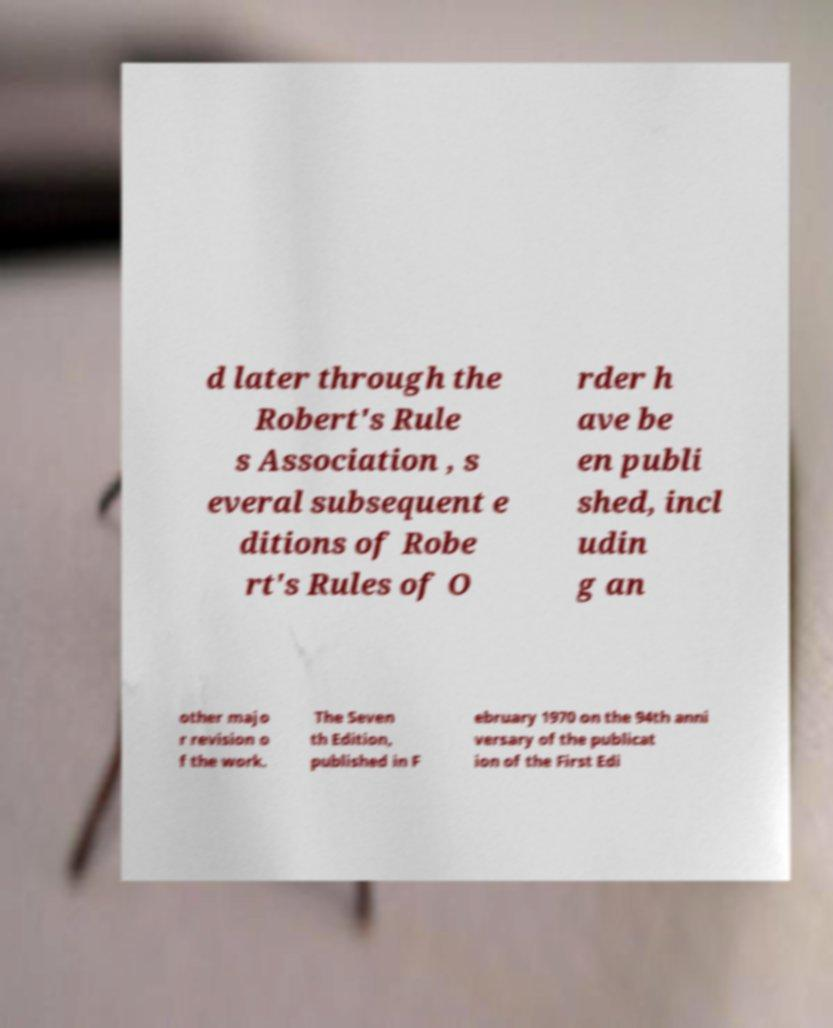Can you read and provide the text displayed in the image?This photo seems to have some interesting text. Can you extract and type it out for me? d later through the Robert's Rule s Association , s everal subsequent e ditions of Robe rt's Rules of O rder h ave be en publi shed, incl udin g an other majo r revision o f the work. The Seven th Edition, published in F ebruary 1970 on the 94th anni versary of the publicat ion of the First Edi 